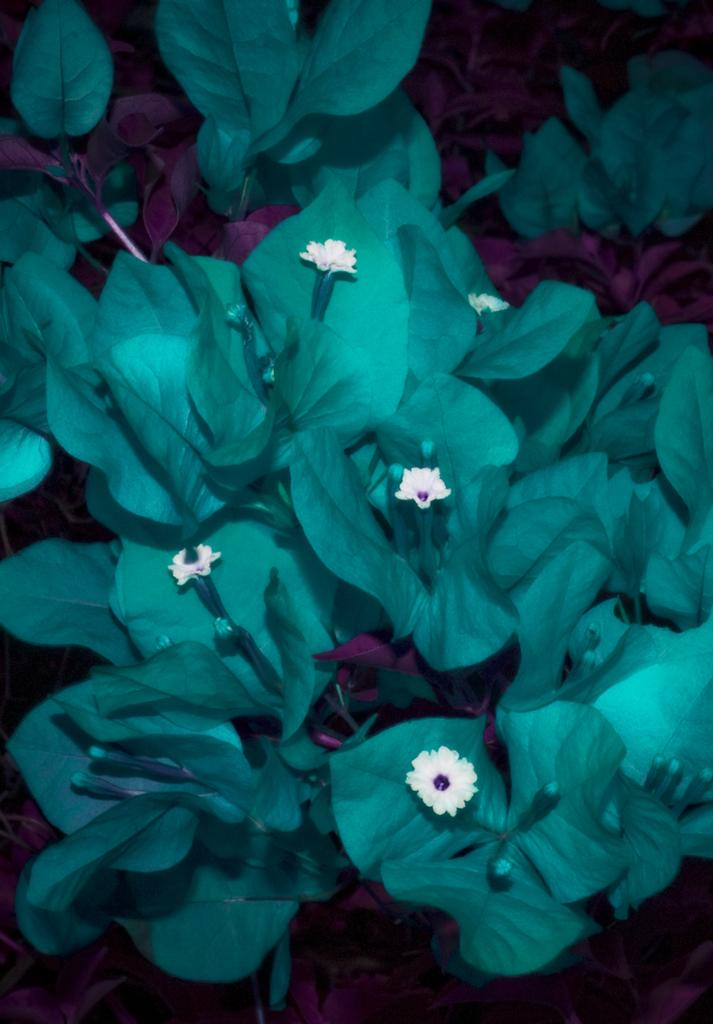What color are the flowers in the image? The flowers in the image are white. What other colors can be seen in the plants in the image? The plants have green and pink colors. What title is given to the flowers in the image? There is no title given to the flowers in the image; they are simply described as white color flowers. 